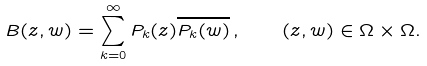Convert formula to latex. <formula><loc_0><loc_0><loc_500><loc_500>B ( z , w ) = \sum _ { k = 0 } ^ { \infty } P _ { k } ( z ) \overline { P _ { k } ( w ) } \, , \quad ( z , w ) \in { \Omega } \times { \Omega } .</formula> 